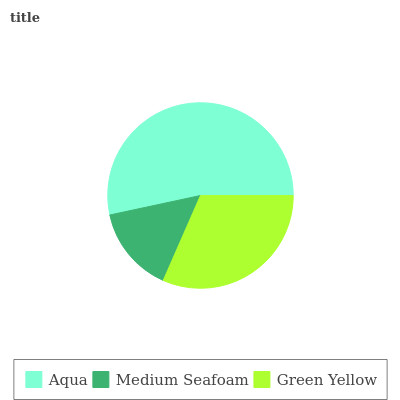Is Medium Seafoam the minimum?
Answer yes or no. Yes. Is Aqua the maximum?
Answer yes or no. Yes. Is Green Yellow the minimum?
Answer yes or no. No. Is Green Yellow the maximum?
Answer yes or no. No. Is Green Yellow greater than Medium Seafoam?
Answer yes or no. Yes. Is Medium Seafoam less than Green Yellow?
Answer yes or no. Yes. Is Medium Seafoam greater than Green Yellow?
Answer yes or no. No. Is Green Yellow less than Medium Seafoam?
Answer yes or no. No. Is Green Yellow the high median?
Answer yes or no. Yes. Is Green Yellow the low median?
Answer yes or no. Yes. Is Aqua the high median?
Answer yes or no. No. Is Aqua the low median?
Answer yes or no. No. 